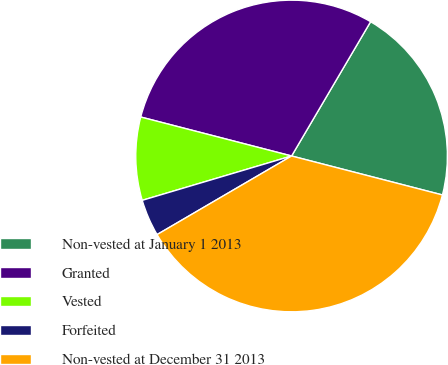Convert chart to OTSL. <chart><loc_0><loc_0><loc_500><loc_500><pie_chart><fcel>Non-vested at January 1 2013<fcel>Granted<fcel>Vested<fcel>Forfeited<fcel>Non-vested at December 31 2013<nl><fcel>20.56%<fcel>29.44%<fcel>8.62%<fcel>3.82%<fcel>37.56%<nl></chart> 